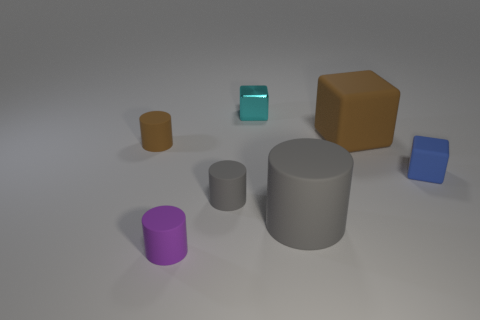Subtract 1 cylinders. How many cylinders are left? 3 Add 1 small yellow shiny objects. How many objects exist? 8 Subtract all blocks. How many objects are left? 4 Add 6 big yellow things. How many big yellow things exist? 6 Subtract 0 gray cubes. How many objects are left? 7 Subtract all gray matte cylinders. Subtract all green rubber blocks. How many objects are left? 5 Add 2 big objects. How many big objects are left? 4 